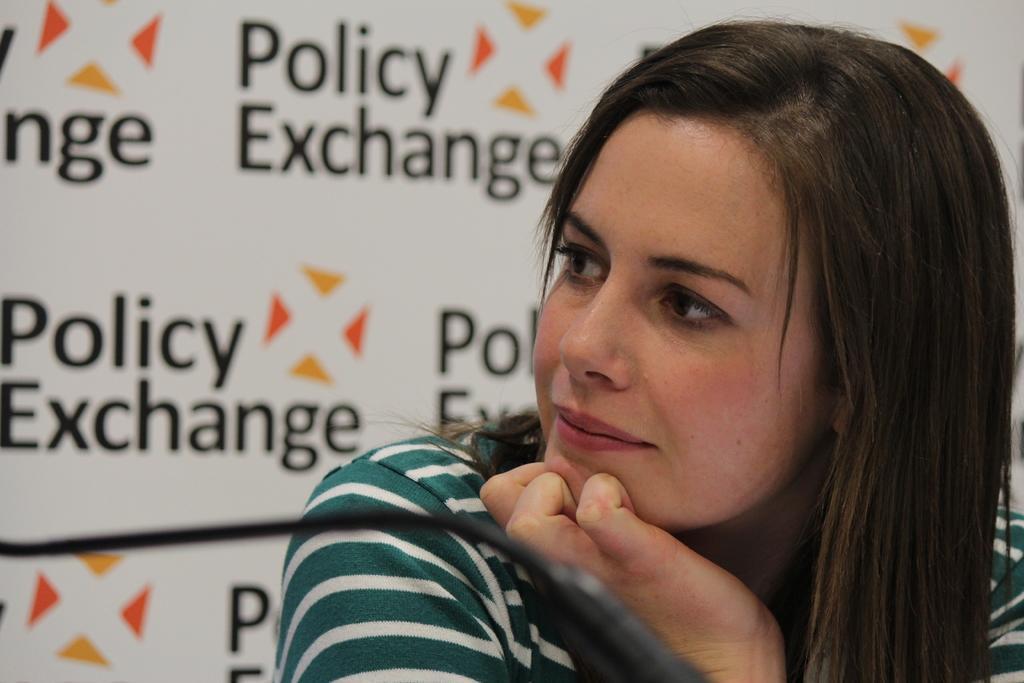In one or two sentences, can you explain what this image depicts? In this image I can see the person with white and cream color dress. To the back of the person I can see the banner and the name policy exchange is written on it. 